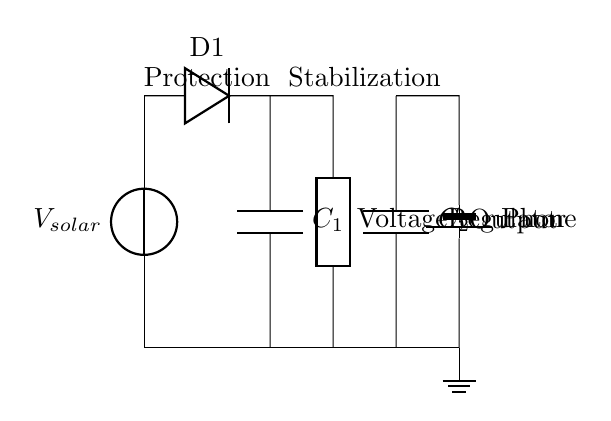What type of circuit is shown? The circuit depicted is a voltage regulator circuit designed for a homemade solar-powered phone charger. A voltage regulator is specifically included to ensure that the output voltage remains stable despite variations in the input voltage from the solar panel.
Answer: Voltage regulator What component provides protection to the circuit? The diode (D1) in the circuit serves as the protective component. It prevents reverse current flow from the battery back to the solar panel, which could potentially damage it.
Answer: Diode What is the purpose of the voltage regulator in this circuit? The voltage regulator stabilizes the output voltage to ensure that the phone receives a constant and appropriate voltage level, regardless of fluctuations in the solar panel output.
Answer: Stabilization How many capacitors are present in the circuit? There are two capacitors labeled as C1 and C2 in the circuit. These capacitors help in smoothing out voltage variations and ensuring a steady output.
Answer: Two Which component connects the solar panel to the voltage regulator? The diode connects the solar panel to the voltage regulator. It is placed in a manner that allows current to flow towards the regulator while blocking any reverse flow.
Answer: Diode What is the role of capacitor C1 in the circuit? Capacitor C1 functions to smooth the voltage output from the voltage regulator by reducing voltage ripples, helping maintain a steady voltage supply to the phone.
Answer: Smoothing What is the output load in this circuit? The output load in the circuit is the phone, represented by the battery symbol. The phone is connected directly to the output side of the voltage regulator for charging.
Answer: Phone 